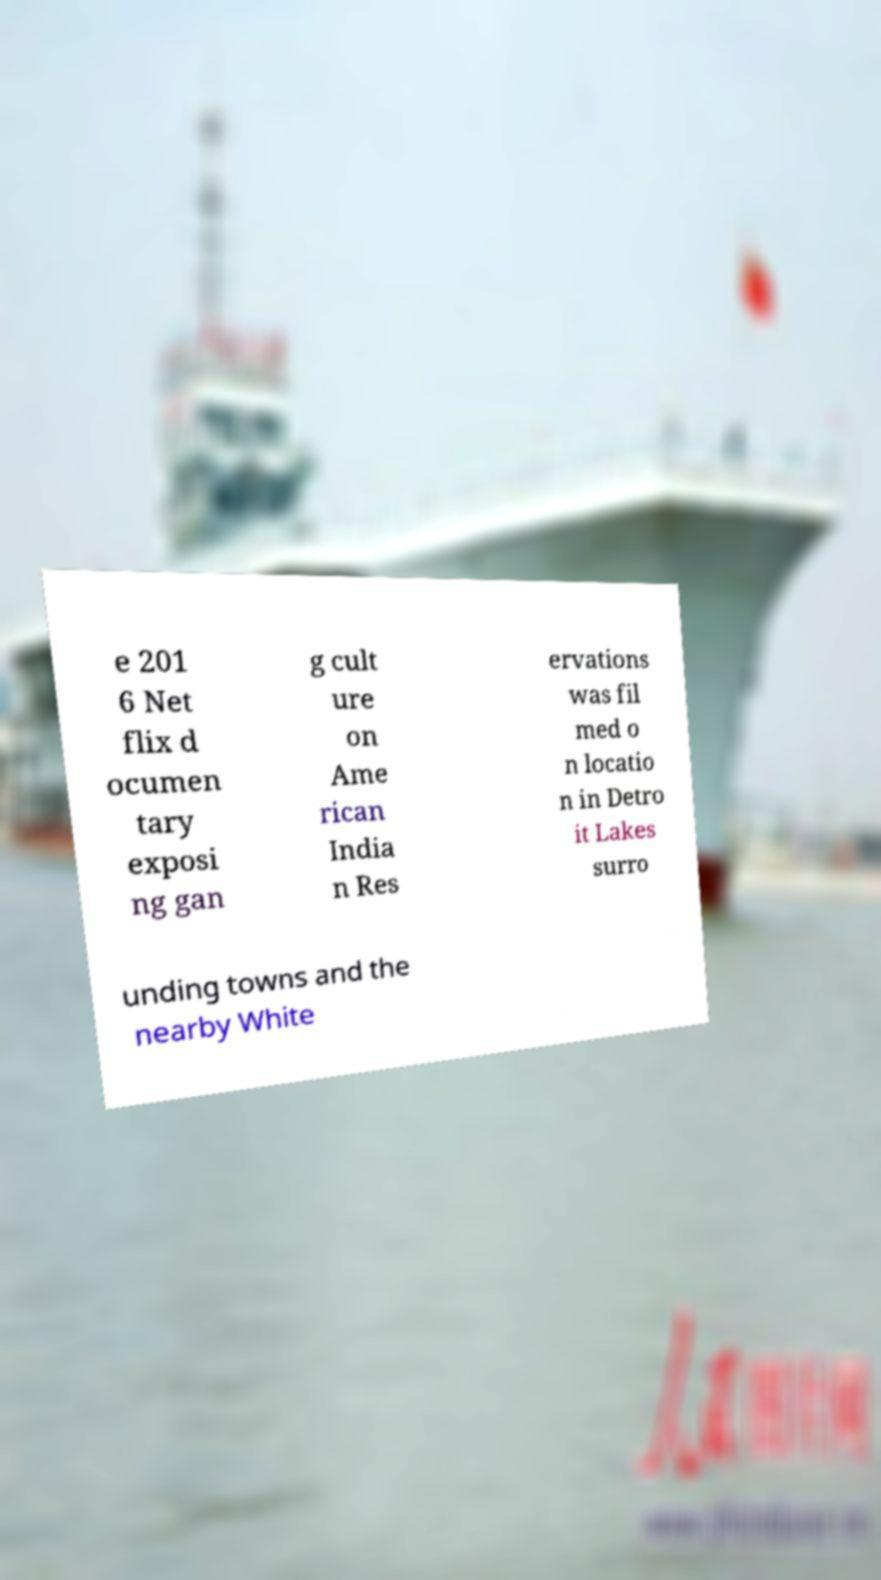Could you assist in decoding the text presented in this image and type it out clearly? e 201 6 Net flix d ocumen tary exposi ng gan g cult ure on Ame rican India n Res ervations was fil med o n locatio n in Detro it Lakes surro unding towns and the nearby White 